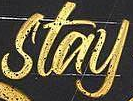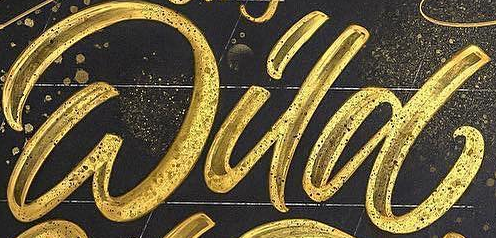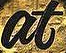Transcribe the words shown in these images in order, separated by a semicolon. stay; Wild; at 